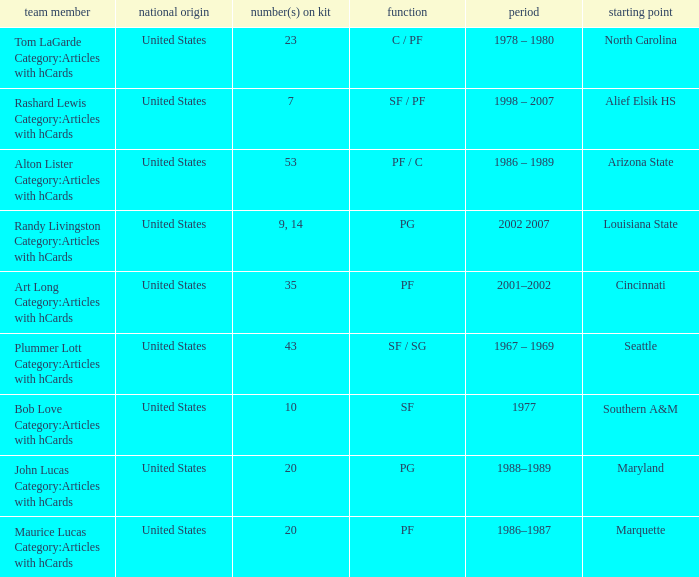The player from Alief Elsik Hs has what as a nationality? United States. 